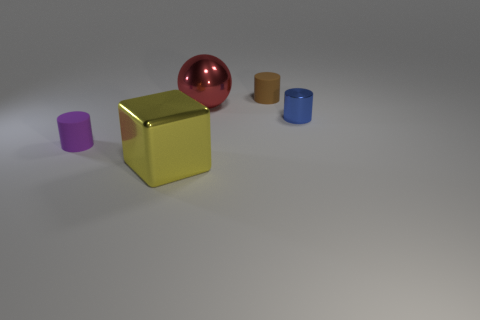What is the large yellow thing that is right of the matte thing that is to the left of the rubber object behind the big metal sphere made of? metal 